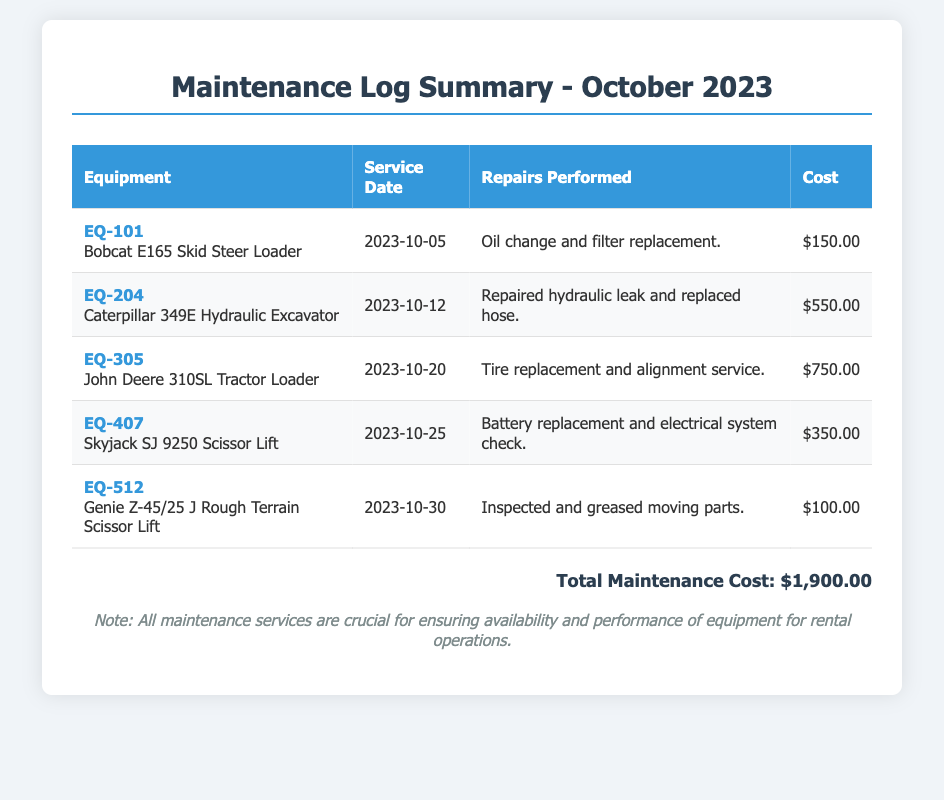What is the total maintenance cost? The total maintenance cost is indicated at the bottom of the document as the sum of all repairs done in October 2023, which amounts to $1,900.00.
Answer: $1,900.00 How many pieces of equipment were serviced in October 2023? The number of pieces of equipment serviced is found by counting the rows in the maintenance log summary table, which lists five entries.
Answer: 5 What equipment had a service date on the 12th? The equipment serviced on the 12th is detailed in the table, specifically the Caterpillar 349E Hydraulic Excavator.
Answer: Caterpillar 349E Hydraulic Excavator Which equipment required a battery replacement? The equipment that needed a battery replacement is specified in the table as the Skyjack SJ 9250 Scissor Lift.
Answer: Skyjack SJ 9250 Scissor Lift What was the cost for the tire replacement service? The cost of the tire replacement service is located in the table, beside the John Deere 310SL Tractor Loader entry, which is $750.00.
Answer: $750.00 How many repairs involved a leak? The number of repairs that included a leak can be determined by checking the table, which shows one instance for the Caterpillar 349E Hydraulic Excavator.
Answer: 1 What service was performed on EQ-512? The service performed on EQ-512 is listed in the document as "Inspected and greased moving parts."
Answer: Inspected and greased moving parts Which piece of equipment is the last listed in the summary? The last piece of equipment in the summary is found in the last row of the table, which is the Genie Z-45/25 J Rough Terrain Scissor Lift.
Answer: Genie Z-45/25 J Rough Terrain Scissor Lift 